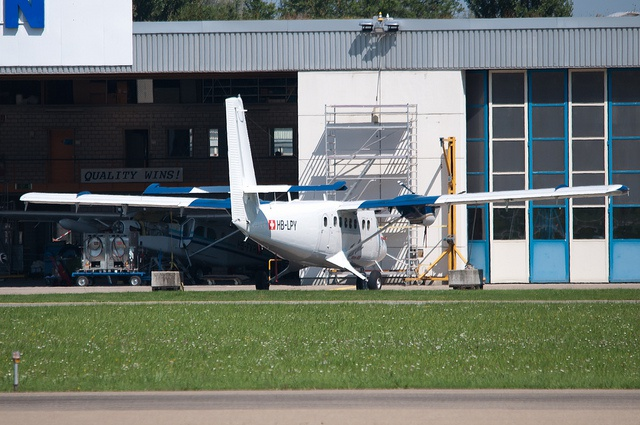Describe the objects in this image and their specific colors. I can see airplane in lavender, white, gray, darkgray, and black tones and airplane in lavender, black, darkblue, and gray tones in this image. 